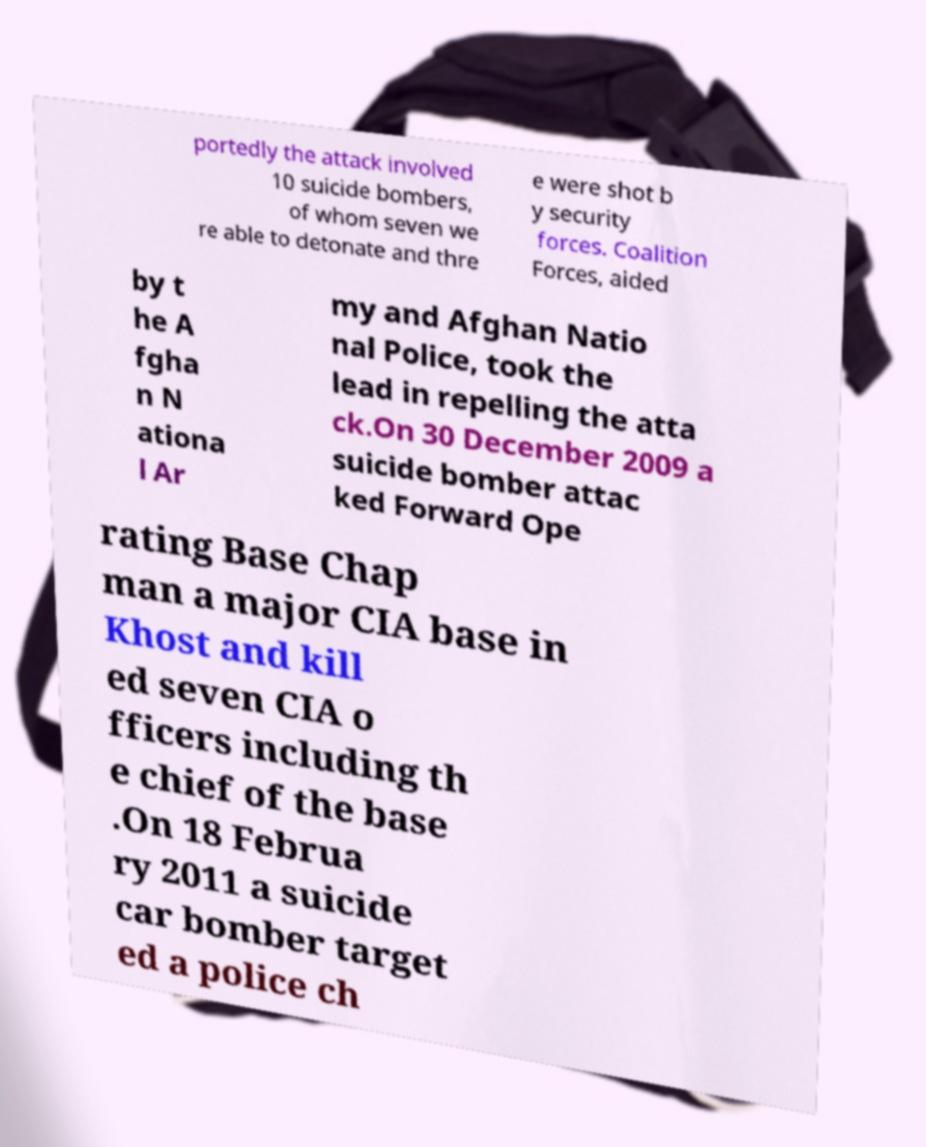Please read and relay the text visible in this image. What does it say? portedly the attack involved 10 suicide bombers, of whom seven we re able to detonate and thre e were shot b y security forces. Coalition Forces, aided by t he A fgha n N ationa l Ar my and Afghan Natio nal Police, took the lead in repelling the atta ck.On 30 December 2009 a suicide bomber attac ked Forward Ope rating Base Chap man a major CIA base in Khost and kill ed seven CIA o fficers including th e chief of the base .On 18 Februa ry 2011 a suicide car bomber target ed a police ch 